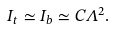<formula> <loc_0><loc_0><loc_500><loc_500>I _ { t } \simeq I _ { b } \simeq C \Lambda ^ { 2 } .</formula> 